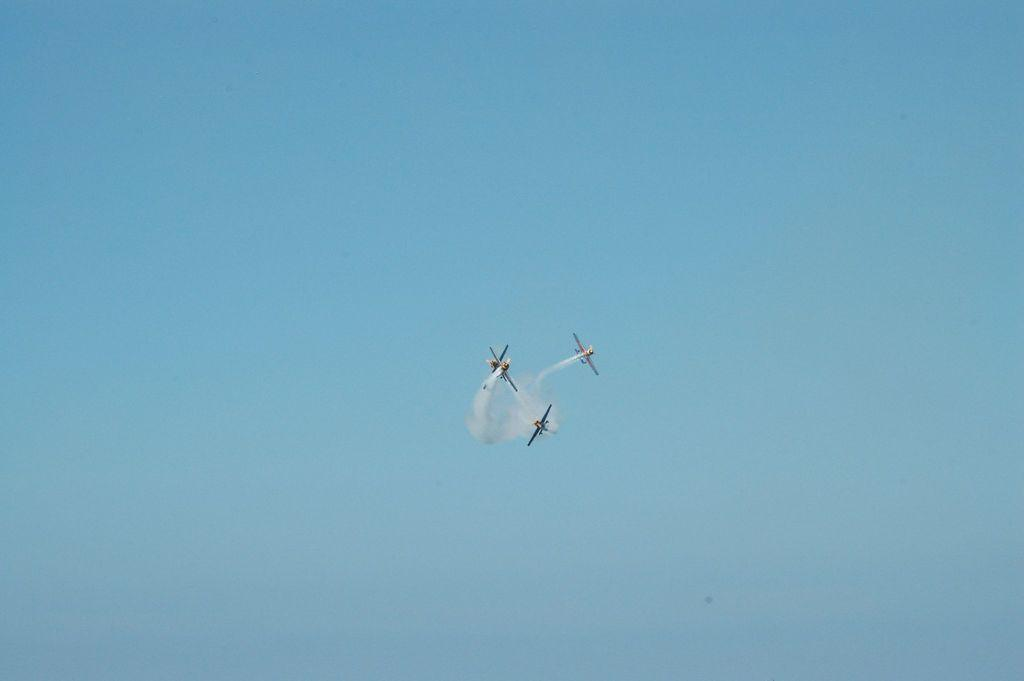What is the main subject of the image? The main subject of the image is aeroplanes. What are the aeroplanes doing in the image? The aeroplanes are flying in the sky. What shape is the egg in the image? There is no egg present in the image. How many spades are visible in the image? There are no spades present in the image. 